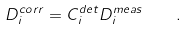<formula> <loc_0><loc_0><loc_500><loc_500>D ^ { c o r r } _ { i } = C ^ { d e t } _ { i } D ^ { m e a s } _ { i } \quad .</formula> 